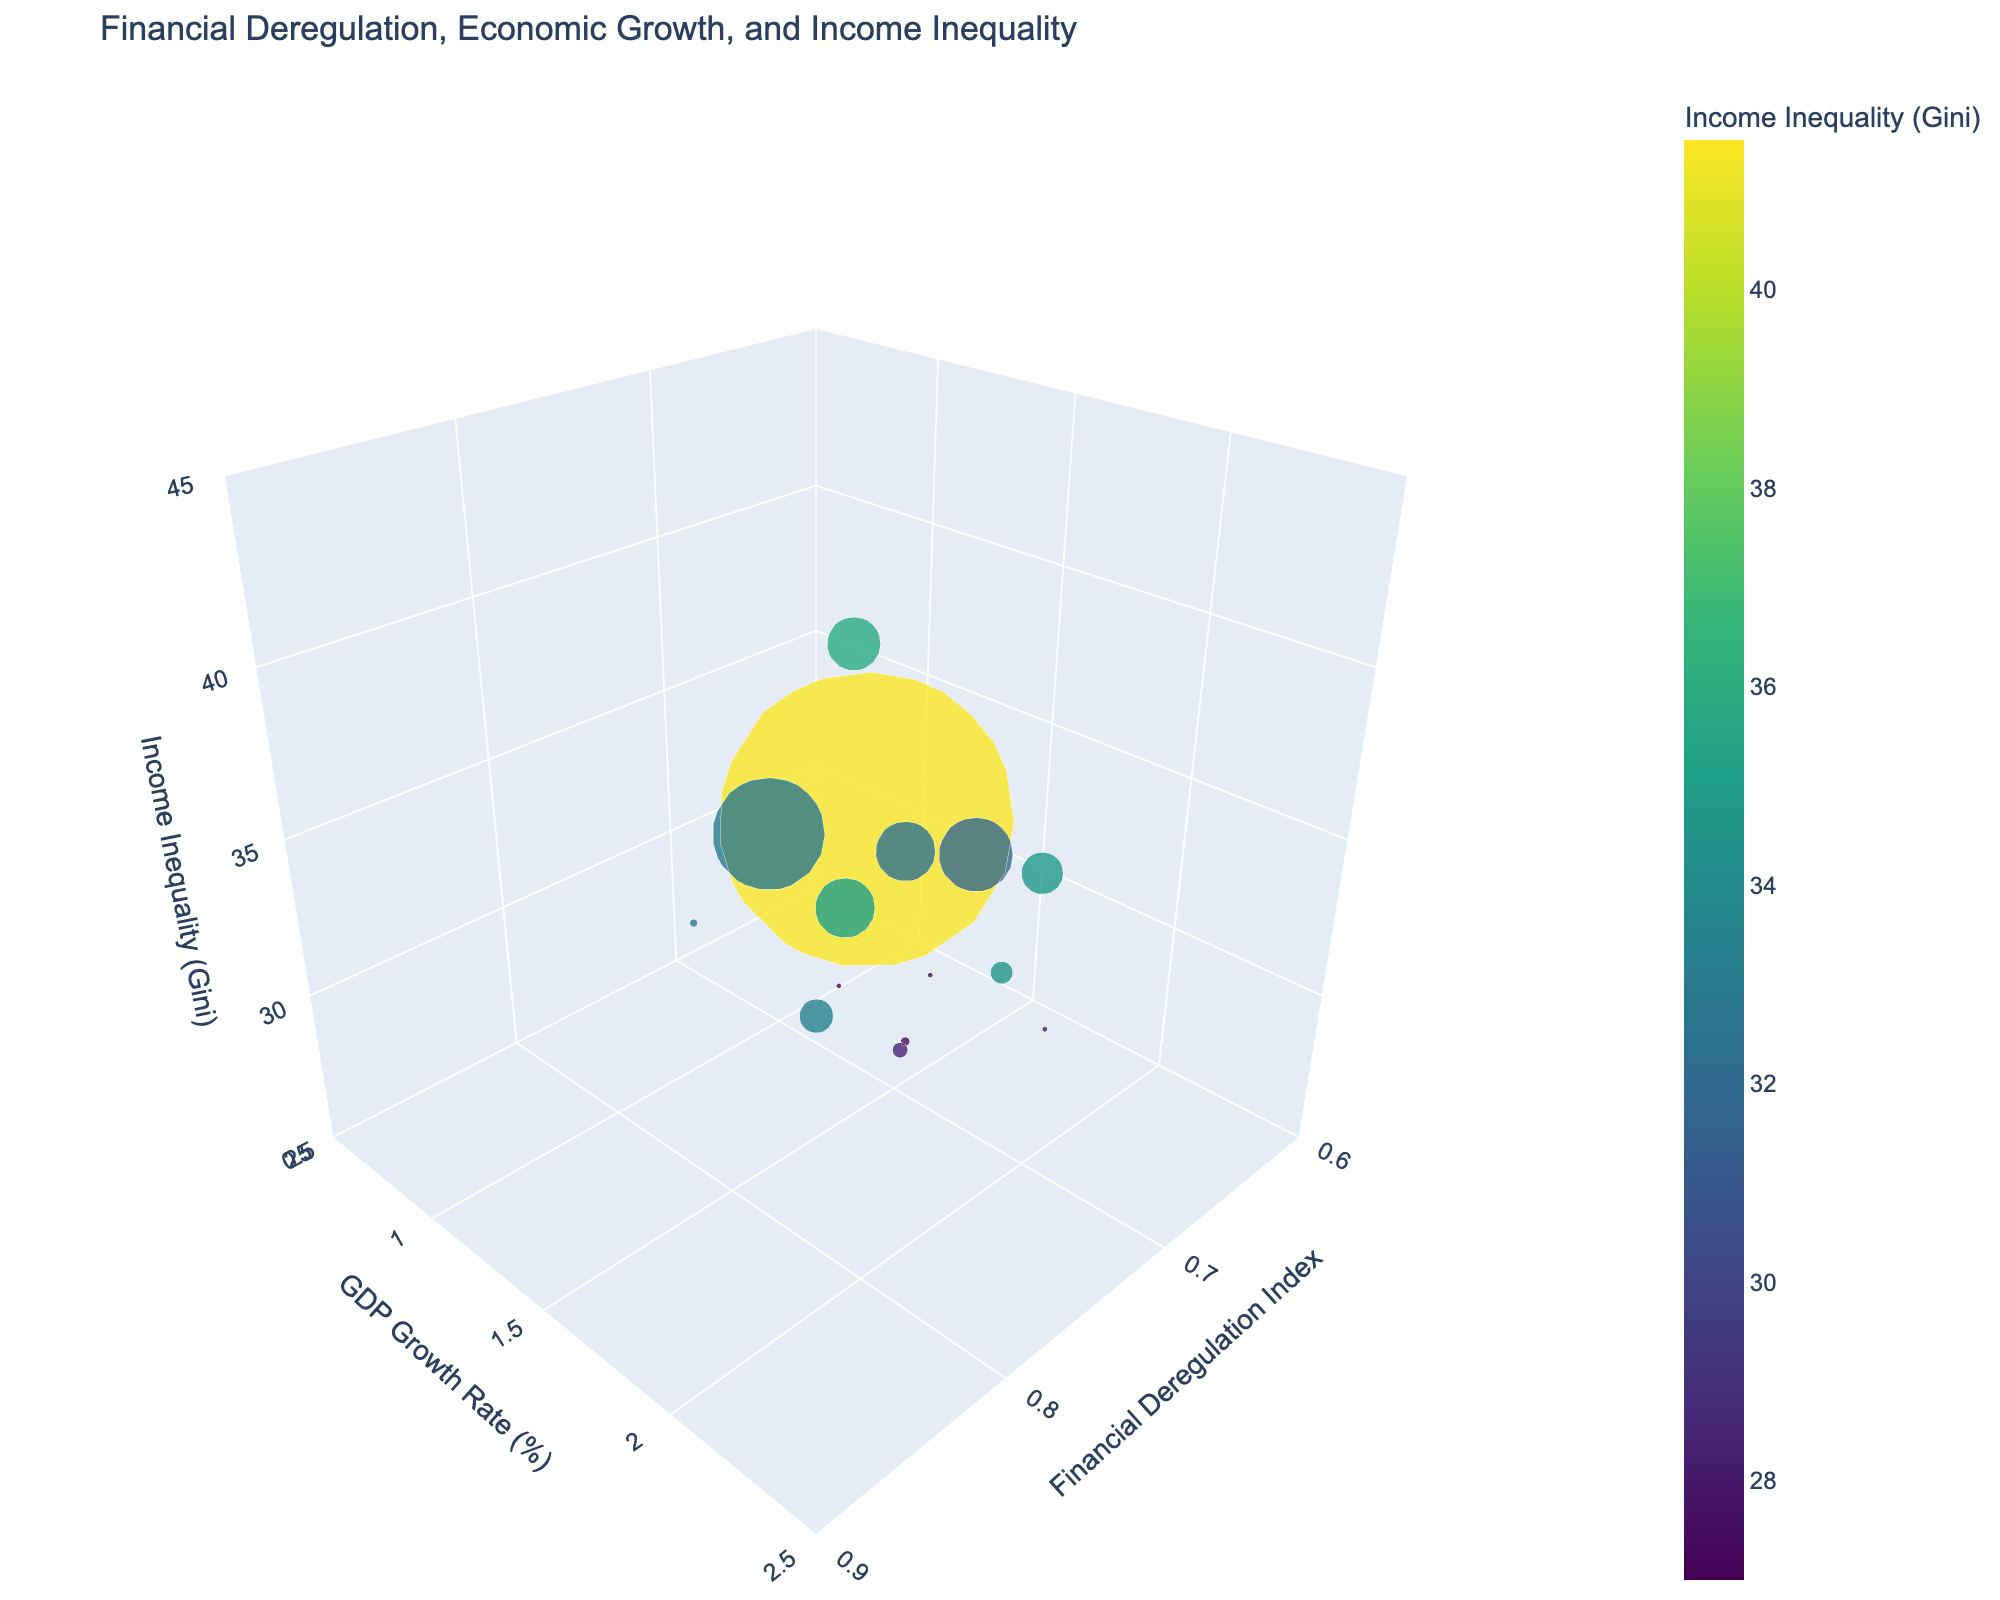What are the axes titles in the figure? The title of the x-axis is 'Financial Deregulation Index', the title of the y-axis is 'GDP Growth Rate (%)', and the title of the z-axis is 'Income Inequality (Gini)'.
Answer: Financial Deregulation Index, GDP Growth Rate (%), Income Inequality (Gini) How is the bubble size determined in the plot? The size of the bubbles is determined by the population of each country, divided by 2 to scale down the size.
Answer: Population Which country has the highest GDP growth rate on the figure? By looking at the y-axis values and identifying the highest point, Spain has the highest GDP Growth Rate at 2.0%.
Answer: Spain Which country shows the highest income inequality according to the Gini index? By examining the color and z-axis, the United States has the highest Gini index of 41.5.
Answer: United States Are there any countries with a GDP growth rate higher than 2%? Yes, by looking at the y-axis, the United States (2.3%), Australia (2.2%), and Spain (2.0%) have GDP growth rates higher than 2%.
Answer: Yes What is the range of financial deregulation index values represented in the figure? The x-axis shows the range of financial deregulation index values from 0.62 to 0.85.
Answer: 0.62 to 0.85 Which country shows the lowest income inequality according to the Gini index? By examining the color and z-axis, Sweden has the lowest Gini index of 27.6.
Answer: Sweden How is the color of each bubble determined? The color of each bubble is determined by the Income Inequality Gini index, with a color scale from the Viridis palette.
Answer: Income Inequality Gini index Compare the financial deregulation index of Canada and Germany. Which country has a higher index? The x-axis values show that Canada has a financial deregulation index of 0.81, whereas Germany has 0.65. Therefore, Canada has a higher financial deregulation index.
Answer: Canada What is the bubble size for Italy in the figure? The population of Italy is 60 million, and the bubble size is adjusted by dividing this number by 2, resulting in a bubble size of 30 million.
Answer: 30 million 